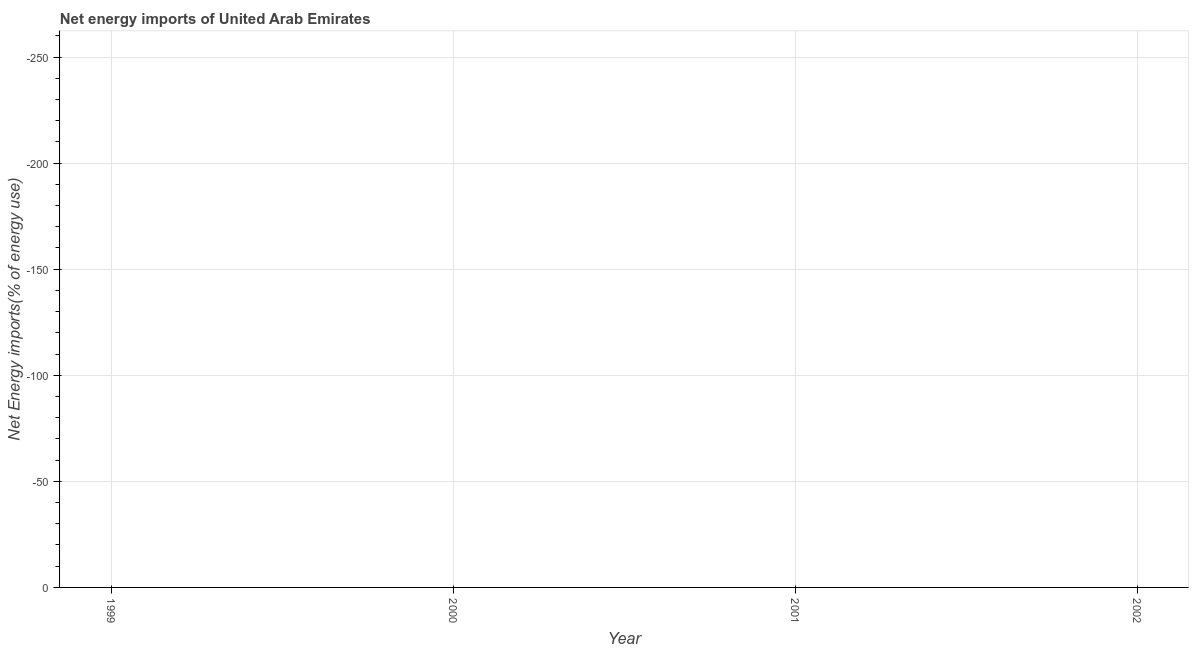What is the energy imports in 2002?
Ensure brevity in your answer.  0. In how many years, is the energy imports greater than -220 %?
Your answer should be very brief. 0. How many lines are there?
Your answer should be very brief. 0. Are the values on the major ticks of Y-axis written in scientific E-notation?
Your answer should be very brief. No. What is the title of the graph?
Your answer should be compact. Net energy imports of United Arab Emirates. What is the label or title of the X-axis?
Your answer should be compact. Year. What is the label or title of the Y-axis?
Make the answer very short. Net Energy imports(% of energy use). What is the Net Energy imports(% of energy use) of 2000?
Your answer should be compact. 0. What is the Net Energy imports(% of energy use) in 2001?
Your response must be concise. 0. What is the Net Energy imports(% of energy use) in 2002?
Keep it short and to the point. 0. 